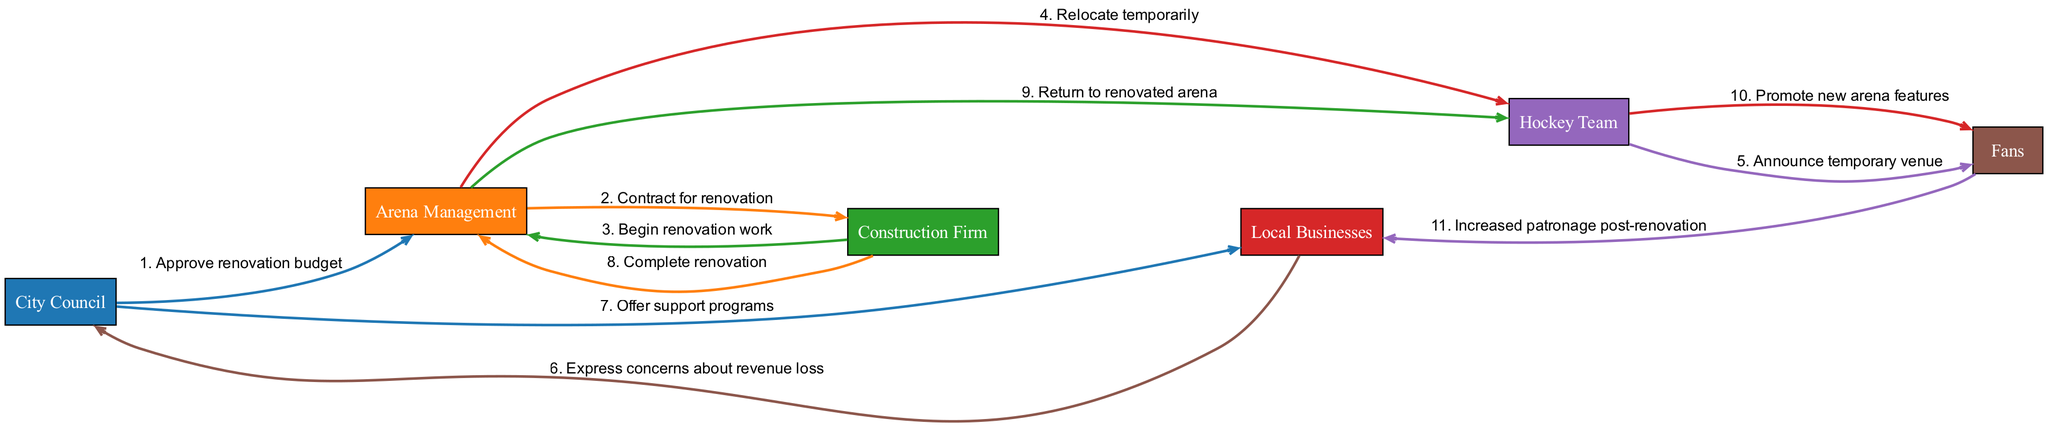What is the first step in the sequence diagram? The first step occurs when the City Council approves the renovation budget, initiating the project. This is the start of the sequence of actions depicted in the diagram.
Answer: Approve renovation budget How many participants are involved in the diagram? The diagram illustrates a total of six distinct participants, as listed in the participants section.
Answer: 6 Who is responsible for completing the renovation? The Construction Firm is tasked with completing the renovation, specifically indicated by the message flowing from the Construction Firm to the Arena Management.
Answer: Construction Firm What action does the Hockey Team take after being relocated? After being relocated temporarily, the Hockey Team announces the temporary venue to the fans, communicating the change necessitated by the renovation.
Answer: Announce temporary venue What is the role of Local Businesses in the sequence? Local Businesses express concerns about revenue loss during the renovation, which highlights their role in the economic impact associated with the construction timeline.
Answer: Express concerns about revenue loss What happens after the renovation is completed? Once the renovation is completed by the Construction Firm, the Arena Management facilitates the Hockey Team's return to the newly renovated arena, marking an important milestone in the sequence of events.
Answer: Return to renovated arena How does the City Council support Local Businesses? The City Council offers support programs to Local Businesses to help mitigate their concerns about revenue loss, demonstrating a proactive approach to community welfare during the renovation period.
Answer: Offer support programs How does fan behavior change after the renovation? After the renovation, fans increase their patronage to Local Businesses, indicating a positive economic impact resulting from the newly renovated arena's appeal.
Answer: Increased patronage post-renovation Which participant communicates the first message? The first message in the sequence is communicated from the City Council to Arena Management, indicating the initial approval necessary for the renovation to commence.
Answer: City Council 